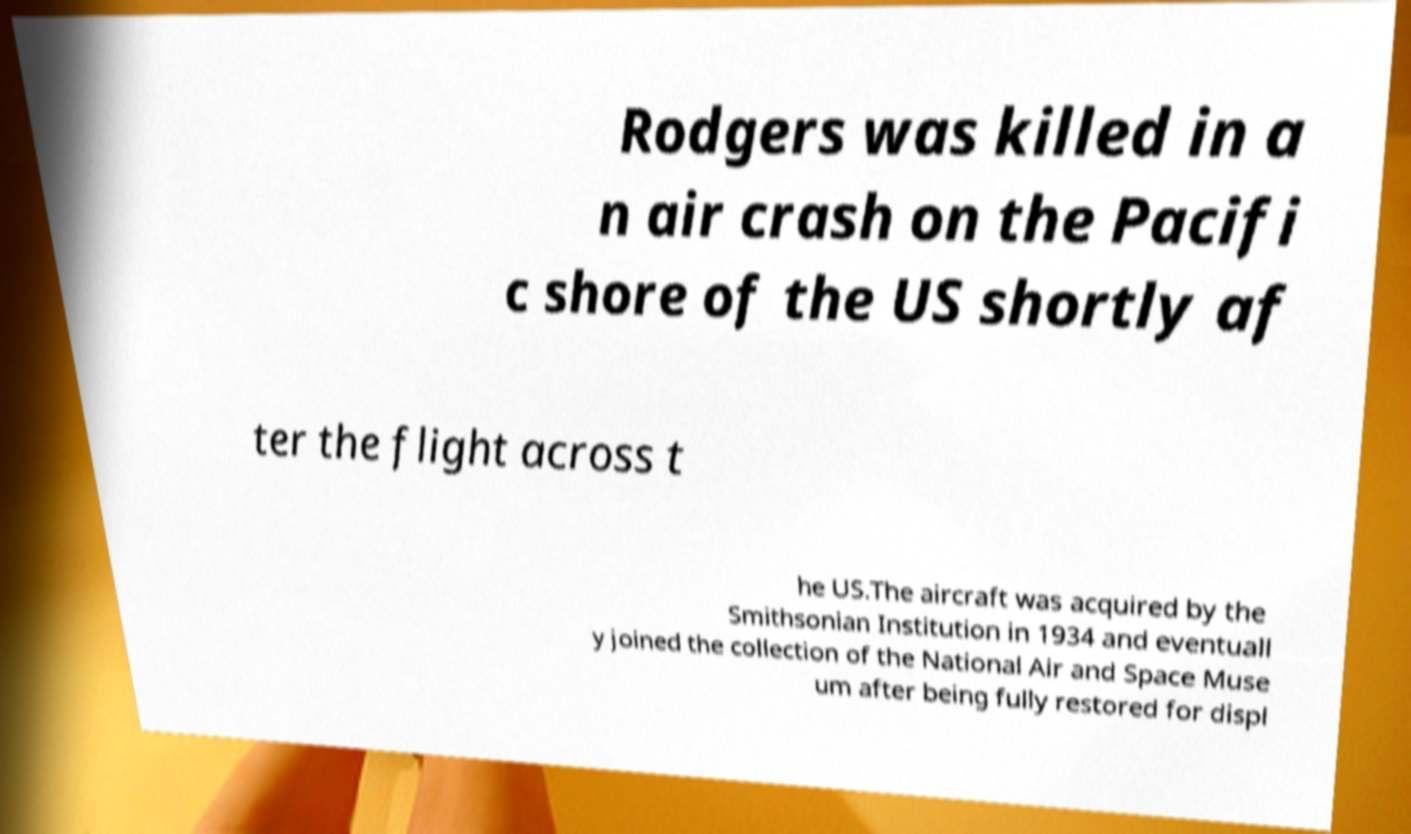What messages or text are displayed in this image? I need them in a readable, typed format. Rodgers was killed in a n air crash on the Pacifi c shore of the US shortly af ter the flight across t he US.The aircraft was acquired by the Smithsonian Institution in 1934 and eventuall y joined the collection of the National Air and Space Muse um after being fully restored for displ 